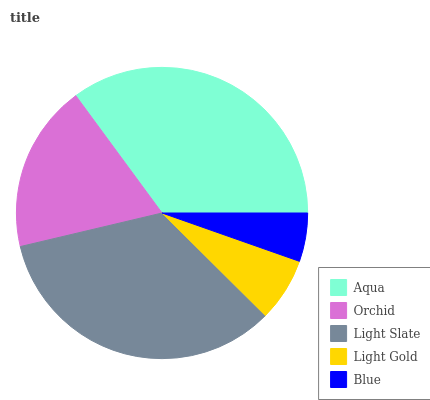Is Blue the minimum?
Answer yes or no. Yes. Is Aqua the maximum?
Answer yes or no. Yes. Is Orchid the minimum?
Answer yes or no. No. Is Orchid the maximum?
Answer yes or no. No. Is Aqua greater than Orchid?
Answer yes or no. Yes. Is Orchid less than Aqua?
Answer yes or no. Yes. Is Orchid greater than Aqua?
Answer yes or no. No. Is Aqua less than Orchid?
Answer yes or no. No. Is Orchid the high median?
Answer yes or no. Yes. Is Orchid the low median?
Answer yes or no. Yes. Is Light Slate the high median?
Answer yes or no. No. Is Aqua the low median?
Answer yes or no. No. 